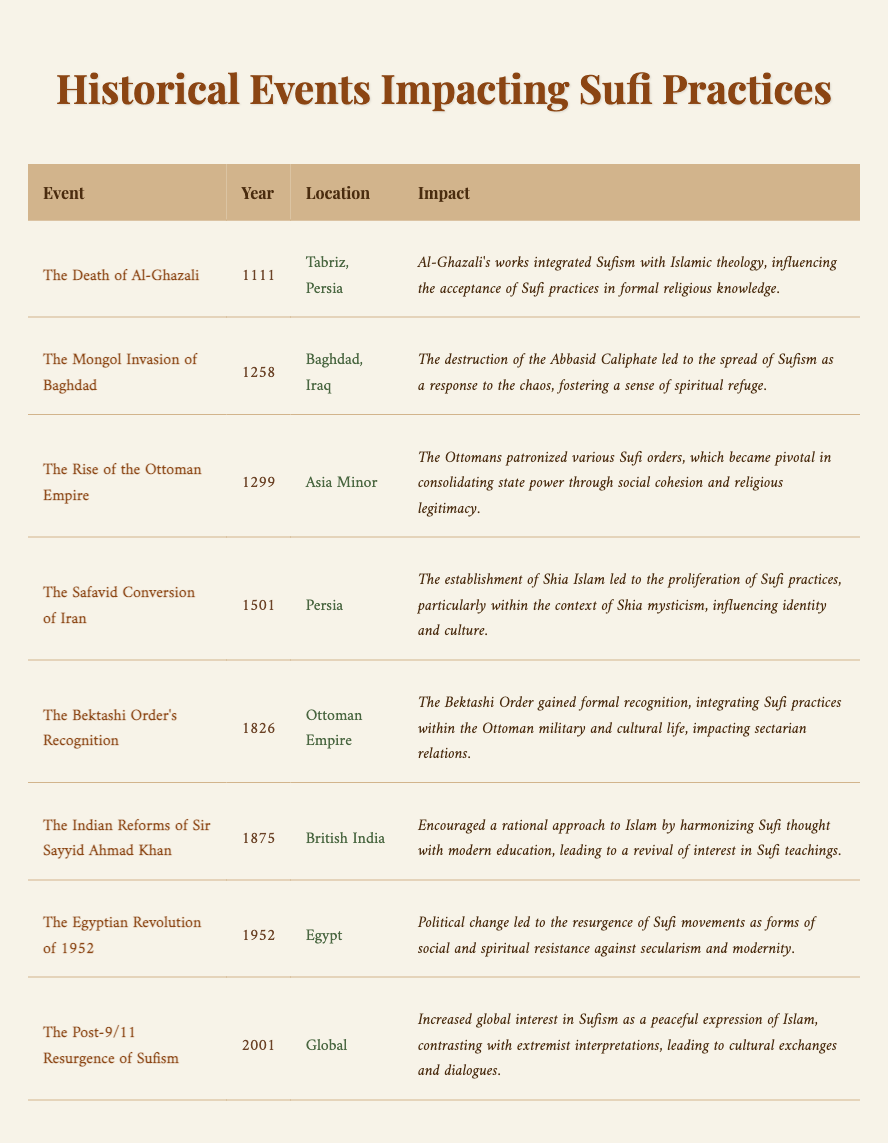What year did the Mongol Invasion of Baghdad occur? The table lists the event "The Mongol Invasion of Baghdad" along with its corresponding year, which is 1258.
Answer: 1258 Which event occurred in Tabriz, Persia? According to the table, "The Death of Al-Ghazali" is noted as occurring in Tabriz, Persia in the year 1111.
Answer: The Death of Al-Ghazali What was the impact of the Safavid Conversion of Iran in 1501? The table states that the Safavid Conversion of Iran led to the proliferation of Sufi practices, particularly influencing identity and culture within the context of Shia mysticism.
Answer: Proliferation of Sufi practices influencing identity and culture How many events listed occurred after 1800? The events occurring after 1800 are "The Bektashi Order's Recognition" (1826), "The Indian Reforms of Sir Sayyid Ahmad Khan" (1875), "The Egyptian Revolution of 1952", and "The Post-9/11 Resurgence of Sufism" (2001). This totals four events.
Answer: 4 Was the rise of the Ottoman Empire in 1299 linked to an increase in Sufi practices? Yes, the table indicates that the Ottomans were patrons of various Sufi orders, thus facilitating a connection between the rise of the Ottoman Empire and an increase in Sufi practices.
Answer: Yes What is the chronological order of events from the table starting from the earliest? The events in chronological order are: "The Death of Al-Ghazali" (1111), "The Mongol Invasion of Baghdad" (1258), "The Rise of the Ottoman Empire" (1299), "The Safavid Conversion of Iran" (1501), "The Bektashi Order's Recognition" (1826), "The Indian Reforms of Sir Sayyid Ahmad Khan" (1875), "The Egyptian Revolution of 1952", and "The Post-9/11 Resurgence of Sufism" (2001).
Answer: Al-Ghazali (1111), Mongol Invasion (1258), Ottoman Rise (1299), Safavid Conversion (1501), Bektashi Recognition (1826), Indian Reforms (1875), Egyptian Revolution (1952), Post-9/11 Resurgence (2001) Which event had the most recent impact on Sufi practices? The most recent event listed in the table is "The Post-9/11 Resurgence of Sufism," which occurred in the year 2001, clearly marking it as the latest event impacting Sufi practices.
Answer: The Post-9/11 Resurgence of Sufism What was the location of the event that occurred in 1952? The table specifies that the event "The Egyptian Revolution" took place in Egypt in the year 1952.
Answer: Egypt How did the Bektashi Order's recognition affect sectarian relations? According to the table, the formal recognition of the Bektashi Order integrated Sufi practices within the Ottoman military and cultural life, impacting sectarian relations positively.
Answer: Integrated Sufi practices in military and culture, positively impacting sectarian relations 